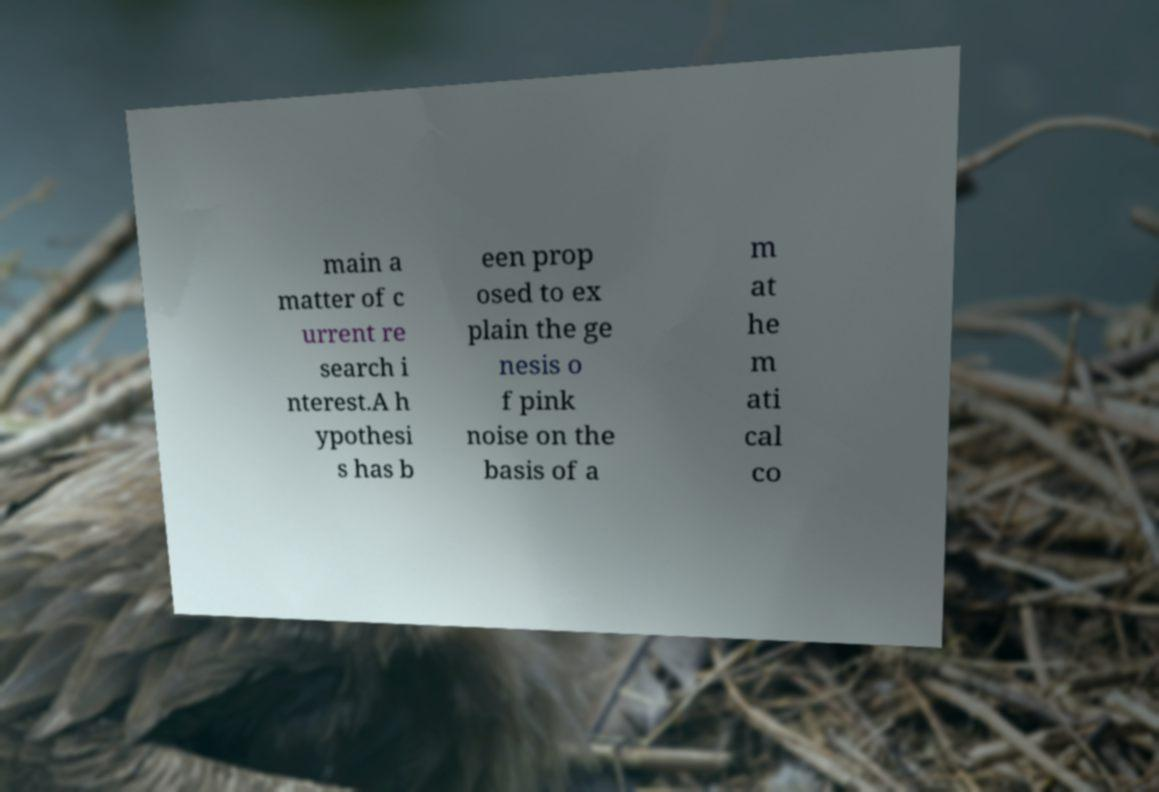Can you accurately transcribe the text from the provided image for me? main a matter of c urrent re search i nterest.A h ypothesi s has b een prop osed to ex plain the ge nesis o f pink noise on the basis of a m at he m ati cal co 